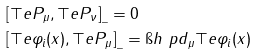Convert formula to latex. <formula><loc_0><loc_0><loc_500><loc_500>& [ \top e { P } _ { \mu } , \top e { P } _ { \nu } ] _ { \_ } = 0 \\ & [ \top e { \varphi } _ { i } ( x ) , \top e { P } _ { \mu } ] _ { \_ } = \i h \ p d _ { \mu } \top e { \varphi } _ { i } ( x )</formula> 